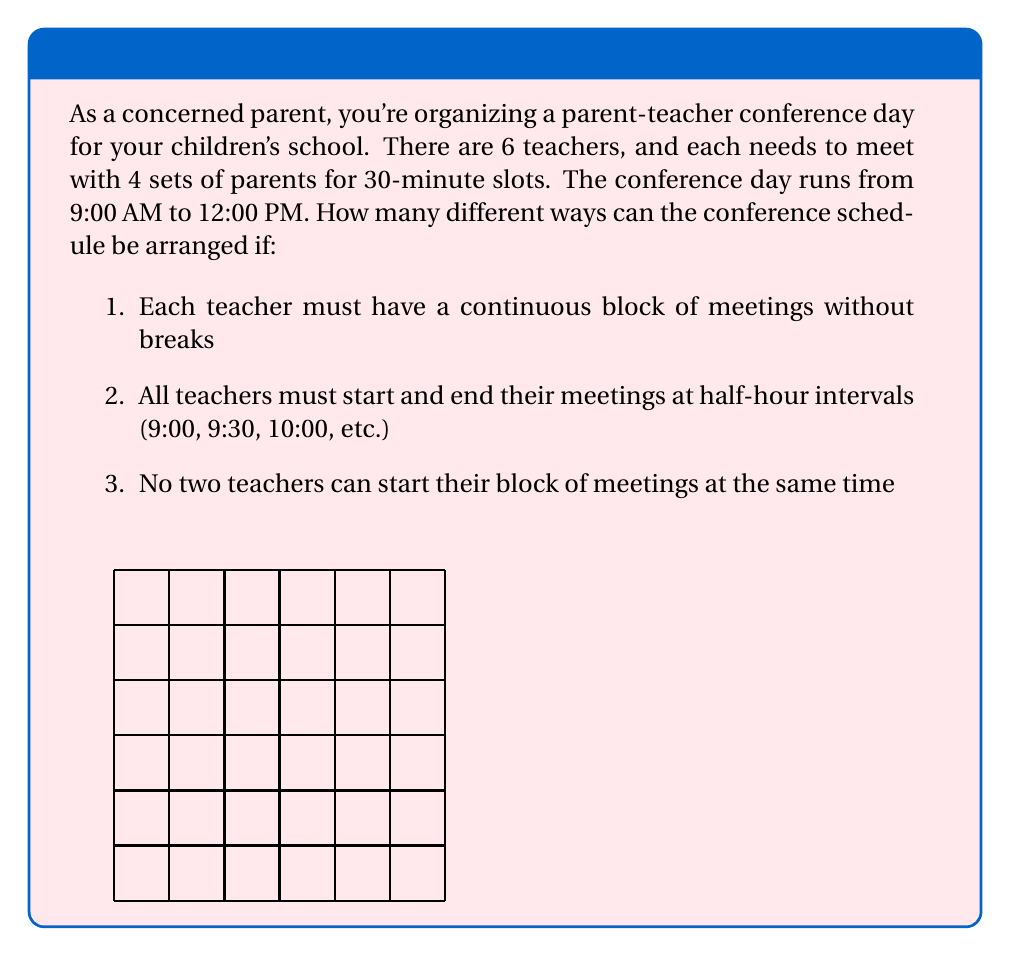Can you answer this question? Let's approach this step-by-step:

1) First, we need to determine how many possible start times there are for each teacher. The conference runs from 9:00 AM to 12:00 PM, which is 3 hours or 6 half-hour slots. Each teacher needs 4 slots (2 hours), so they can start at 9:00, 9:30, or 10:00 to finish by 12:00.

2) Now, we need to choose start times for 6 teachers from these 3 options, with no two teachers starting at the same time. This is a permutation problem.

3) We can think of this as arranging 6 teachers in 6 out of 7 possible slots (3 start times, 3 non-start times, and 1 unused slot at the end).

4) This is equivalent to the number of ways to arrange 6 items in 7 slots, which is given by the permutation formula:

   $$P(7,6) = \frac{7!}{(7-6)!} = \frac{7!}{1!}$$

5) Let's calculate this:
   $$\frac{7!}{1!} = 7 \times 6 \times 5 \times 4 \times 3 \times 2 \times 1 = 5040$$

Therefore, there are 5040 different ways to arrange the conference schedule under the given constraints.
Answer: 5040 